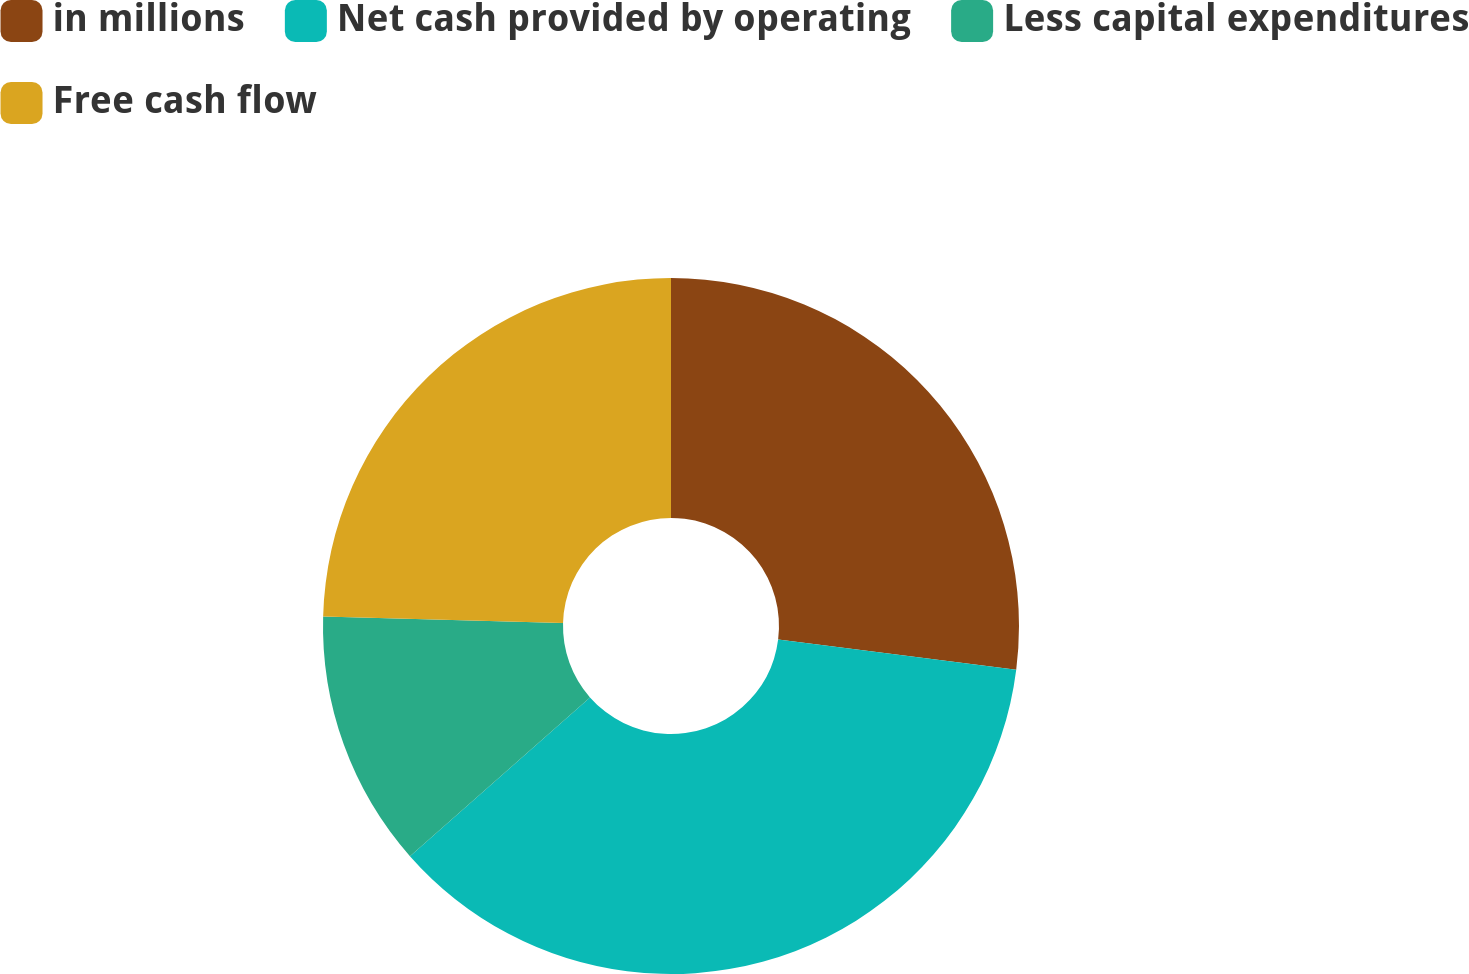Convert chart. <chart><loc_0><loc_0><loc_500><loc_500><pie_chart><fcel>in millions<fcel>Net cash provided by operating<fcel>Less capital expenditures<fcel>Free cash flow<nl><fcel>27.01%<fcel>36.49%<fcel>11.94%<fcel>24.56%<nl></chart> 